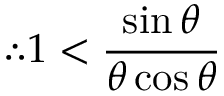Convert formula to latex. <formula><loc_0><loc_0><loc_500><loc_500>\therefore 1 < { \frac { \sin \theta } { \theta \cos \theta } }</formula> 